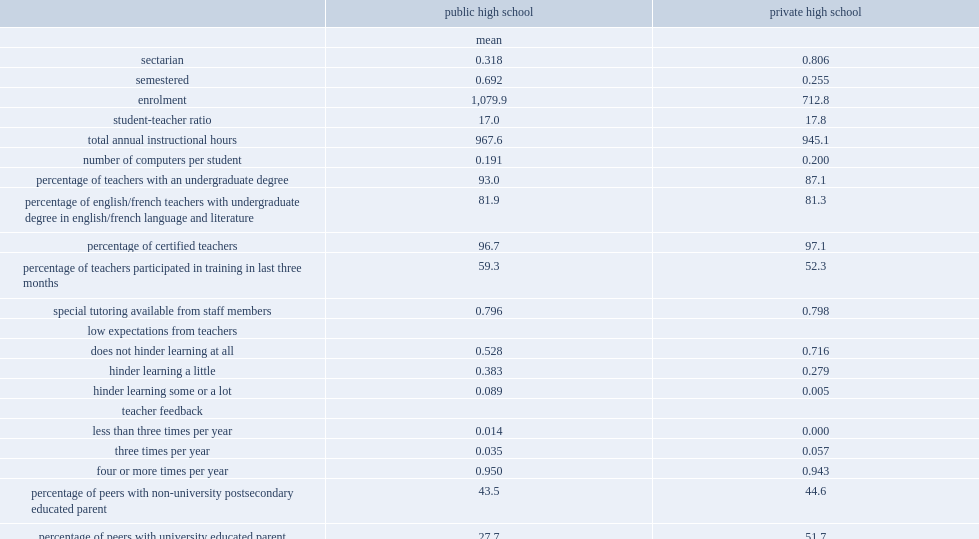Which schools were more likely to be sectarian? Private high school. Which schools were less likely to follow a semester mode? Private high school. Which schools' average student enrollment was considerably lower, public schools or private schools? Private high school. Which schools had the higher student-teacher ratio, public schools or private schools? Public high school. Which schools had the lower average annual number of instructional hours, public schools or private schools? Private high school. Which schools had the higher average number of computers per student, in private schools or public schools? Private high school. A factor that stands out was the extent to which teachers' low expectations hindered learning: what was the percent of public school principals reported that low expectations from teachers hindered learning "some" or "a lot,"? 0.089. A factor that stands out was the extent to which teachers' low expectations hindered learning: what was the percent of private school principals reported that low expectations from teachers hindered learning "some" or "a lot,"? 0.005. In private schools, what was the percent of students had peers with a university-educated parent? 51.7. In public schools, what was the percent of students had peers with a university-educated parent? 27.7. What was the percent of all private school students in quebec? 0.559. What was the percent of all public school students in ontario? 0.484. How many percent of private school students did british columbia account for? 0.223. How many percent of public school students did british columbia account for? 0.159. Write the full table. {'header': ['', 'public high school', 'private high school'], 'rows': [['', 'mean', ''], ['sectarian', '0.318', '0.806'], ['semestered', '0.692', '0.255'], ['enrolment', '1,079.9', '712.8'], ['student-teacher ratio', '17.0', '17.8'], ['total annual instructional hours', '967.6', '945.1'], ['number of computers per student', '0.191', '0.200'], ['percentage of teachers with an undergraduate degree', '93.0', '87.1'], ['percentage of english/french teachers with undergraduate degree in english/french language and literature', '81.9', '81.3'], ['percentage of certified teachers', '96.7', '97.1'], ['percentage of teachers participated in training in last three months', '59.3', '52.3'], ['special tutoring available from staff members', '0.796', '0.798'], ['low expectations from teachers', '', ''], ['does not hinder learning at all', '0.528', '0.716'], ['hinder learning a little', '0.383', '0.279'], ['hinder learning some or a lot', '0.089', '0.005'], ['teacher feedback', '', ''], ['less than three times per year', '0.014', '0.000'], ['three times per year', '0.035', '0.057'], ['four or more times per year', '0.950', '0.943'], ['percentage of peers with non-university postsecondary educated parent', '43.5', '44.6'], ['percentage of peers with university educated parent', '27.7', '51.7'], ['provincial distribution of students', '', ''], ['quebec', '0.157', '0.559'], ['ontario', '0.484', '0.118'], ['manitoba', '0.040', '0.050'], ['saskatchewan', '0.044', '0.020'], ['alberta', '0.117', '0.029'], ['british columbia', '0.159', '0.223']]} 